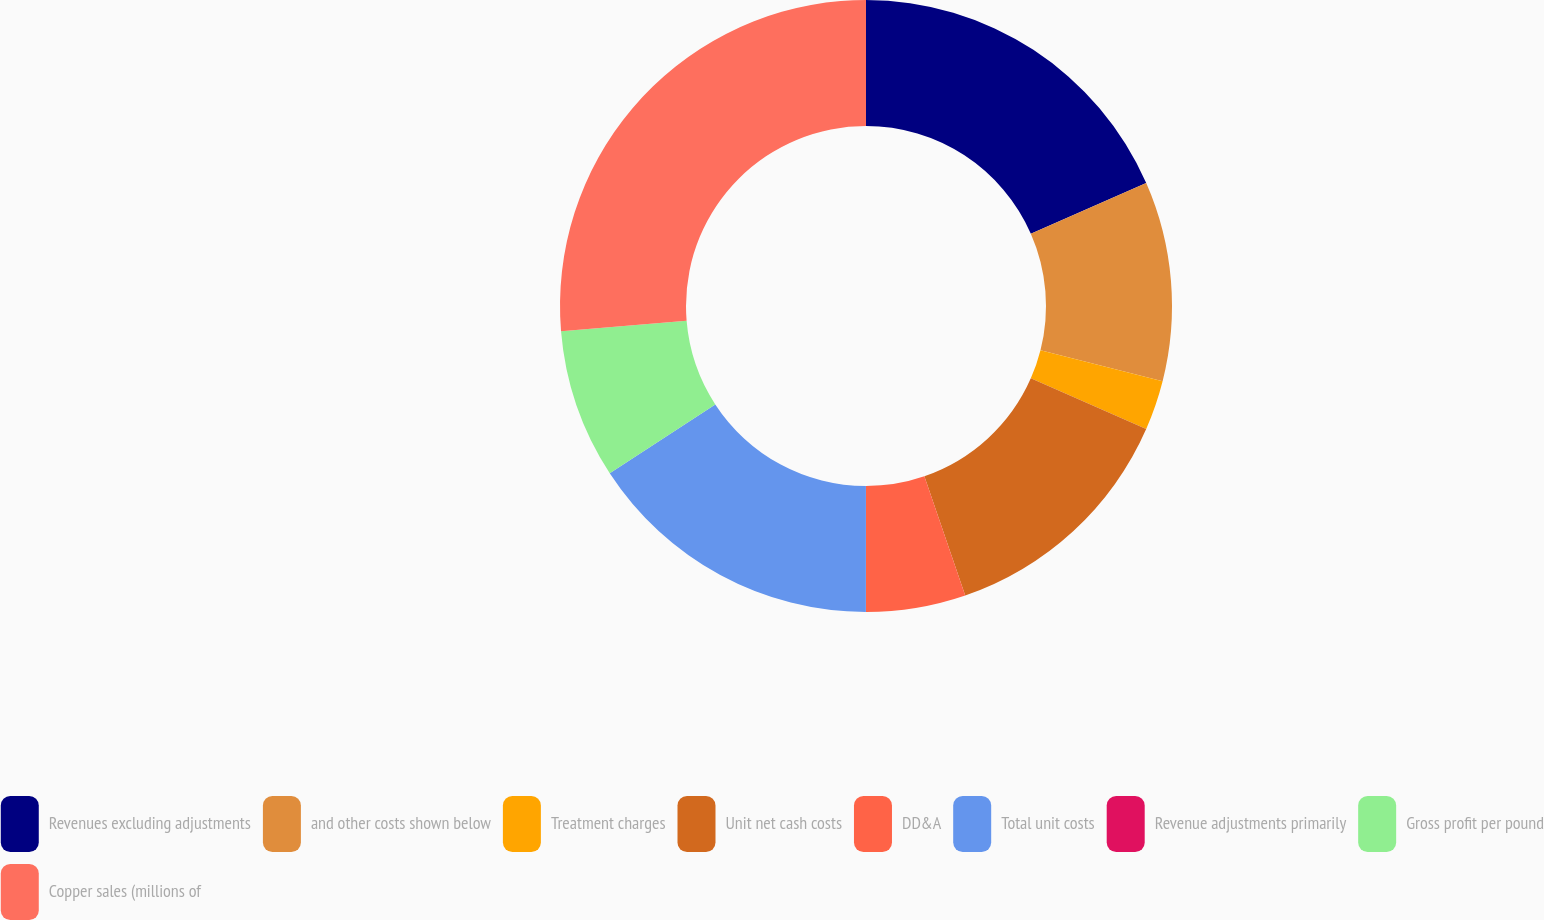<chart> <loc_0><loc_0><loc_500><loc_500><pie_chart><fcel>Revenues excluding adjustments<fcel>and other costs shown below<fcel>Treatment charges<fcel>Unit net cash costs<fcel>DD&A<fcel>Total unit costs<fcel>Revenue adjustments primarily<fcel>Gross profit per pound<fcel>Copper sales (millions of<nl><fcel>18.42%<fcel>10.53%<fcel>2.63%<fcel>13.16%<fcel>5.26%<fcel>15.79%<fcel>0.0%<fcel>7.89%<fcel>26.31%<nl></chart> 